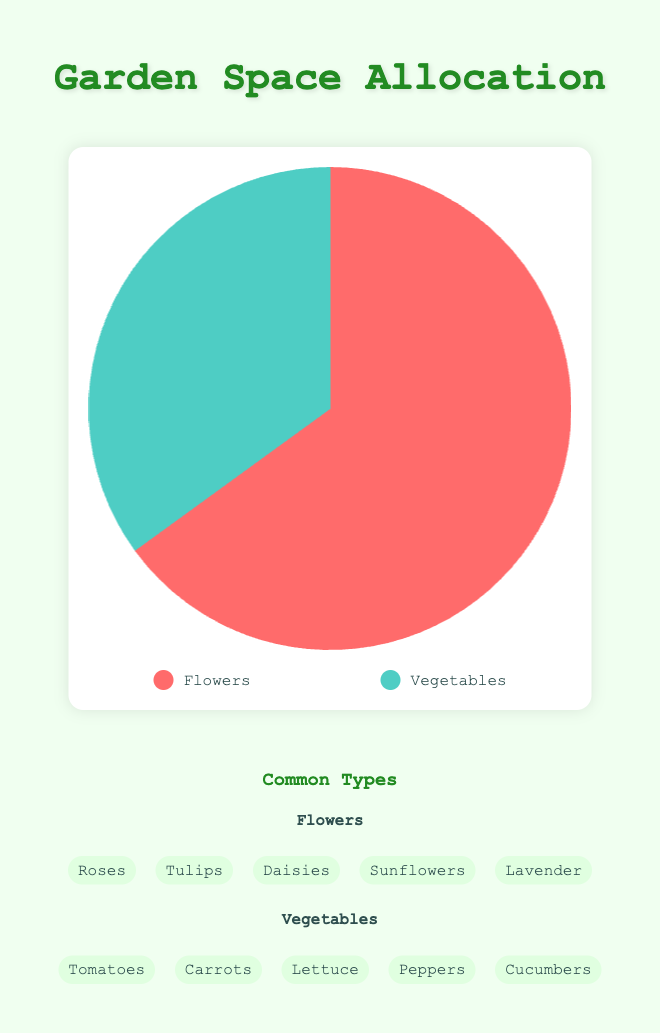Which area has the larger allocation, flowers or vegetables? By referring to the figure, we can see that the slice representing flowers is larger than the slice representing vegetables. The flowers portion is 65% while the vegetables portion is 35%.
Answer: Flowers What percentage of the garden space is allocated to vegetables? According to the figure, the slice representing vegetables takes up 35% of the garden space.
Answer: 35% How much more of the garden space is allocated to flowers compared to vegetables? Referring to the figure, flowers take up 65% and vegetables take up 35%. The difference between these two percentages is 65% - 35% = 30%.
Answer: 30% What are some common types of vegetables grown in the garden? The figure lists common vegetables in a section under the pie chart. According to this, the common types of vegetables include Tomatoes, Carrots, Lettuce, Peppers, and Cucumbers.
Answer: Tomatoes, Carrots, Lettuce, Peppers, Cucumbers What is the ratio of flower space to vegetable space in the garden? Flowers occupy 65% and vegetables occupy 35% of the garden. The ratio is therefore 65/35 or simplified to 13/7.
Answer: 13:7 By how much does the garden space allocated to flowers exceed that to vegetables in terms of percentage? The space allocated to flowers is 65%, and to vegetables, it is 35%. The difference, therefore, is 65% - 35% = 30%.
Answer: 30% If 100 square meters is the total garden space, how many square meters are allocated to flowers and vegetables respectively? Flowers occupy 65% of the garden, so 65% of 100 square meters is 65 square meters. Vegetables occupy 35% of the garden, so 35% of 100 square meters is 35 square meters.
Answer: 65 square meters for flowers, 35 square meters for vegetables Which section of the pie is colored red? By observing the figure, it is evident that the section of the pie chart representing flowers is colored red.
Answer: Flowers Which section of the pie is colored green? By referring to the figure, the section of the pie chart for vegetables is colored green.
Answer: Vegetables What are some common types of flowers grown in the garden? The figure lists common flowers in a section under the pie chart. According to this, common types of flowers include Roses, Tulips, Daisies, Sunflowers, and Lavender.
Answer: Roses, Tulips, Daisies, Sunflowers, Lavender 